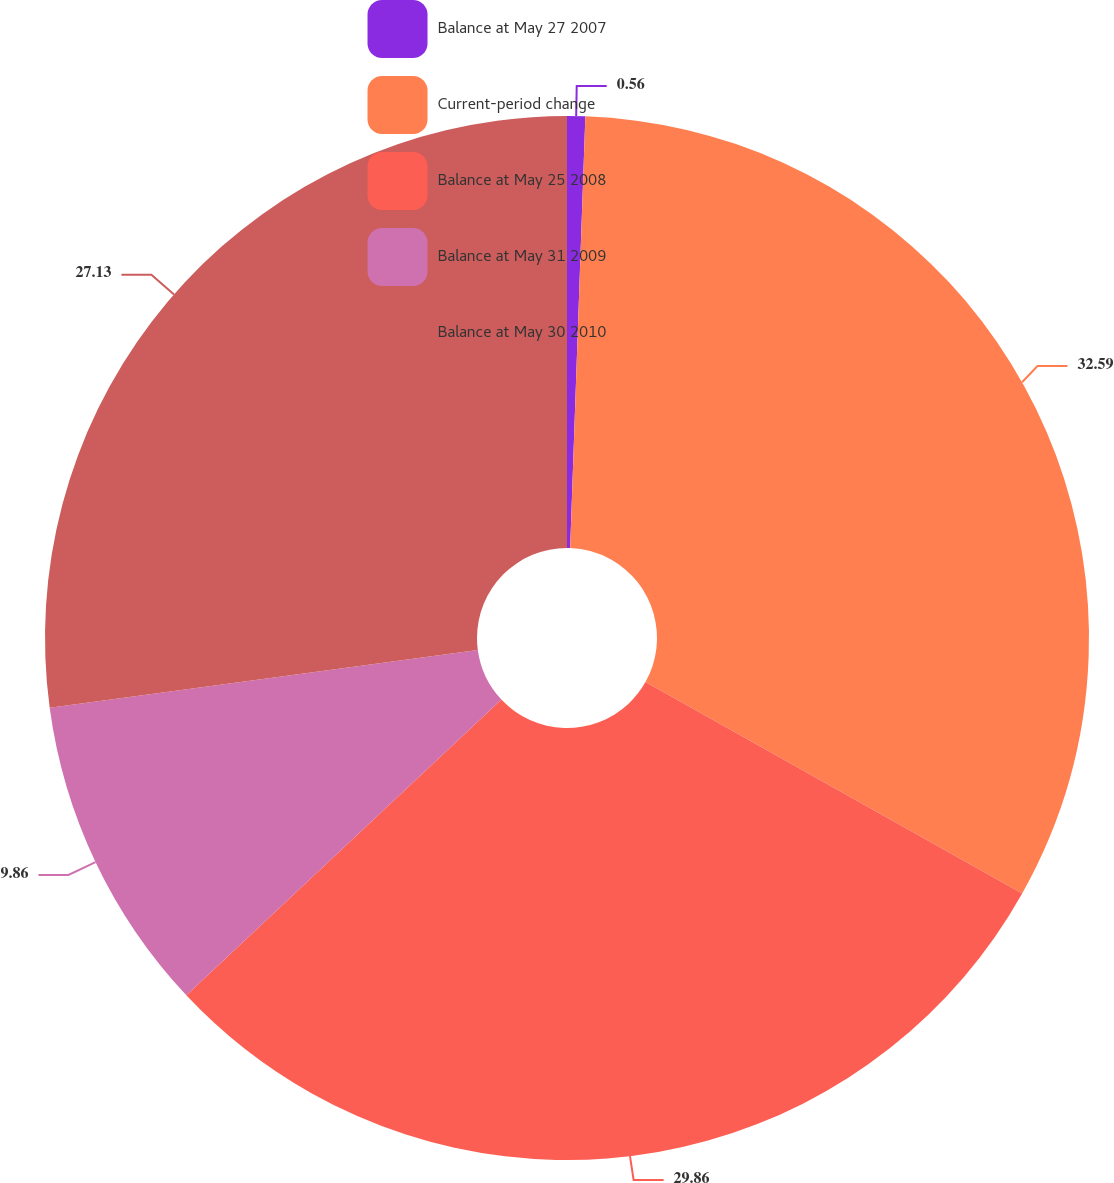Convert chart to OTSL. <chart><loc_0><loc_0><loc_500><loc_500><pie_chart><fcel>Balance at May 27 2007<fcel>Current-period change<fcel>Balance at May 25 2008<fcel>Balance at May 31 2009<fcel>Balance at May 30 2010<nl><fcel>0.56%<fcel>32.58%<fcel>29.86%<fcel>9.86%<fcel>27.13%<nl></chart> 